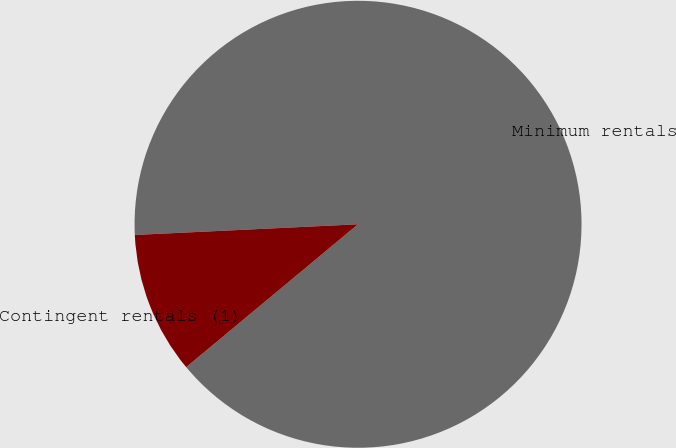<chart> <loc_0><loc_0><loc_500><loc_500><pie_chart><fcel>Minimum rentals<fcel>Contingent rentals (1)<nl><fcel>89.72%<fcel>10.28%<nl></chart> 